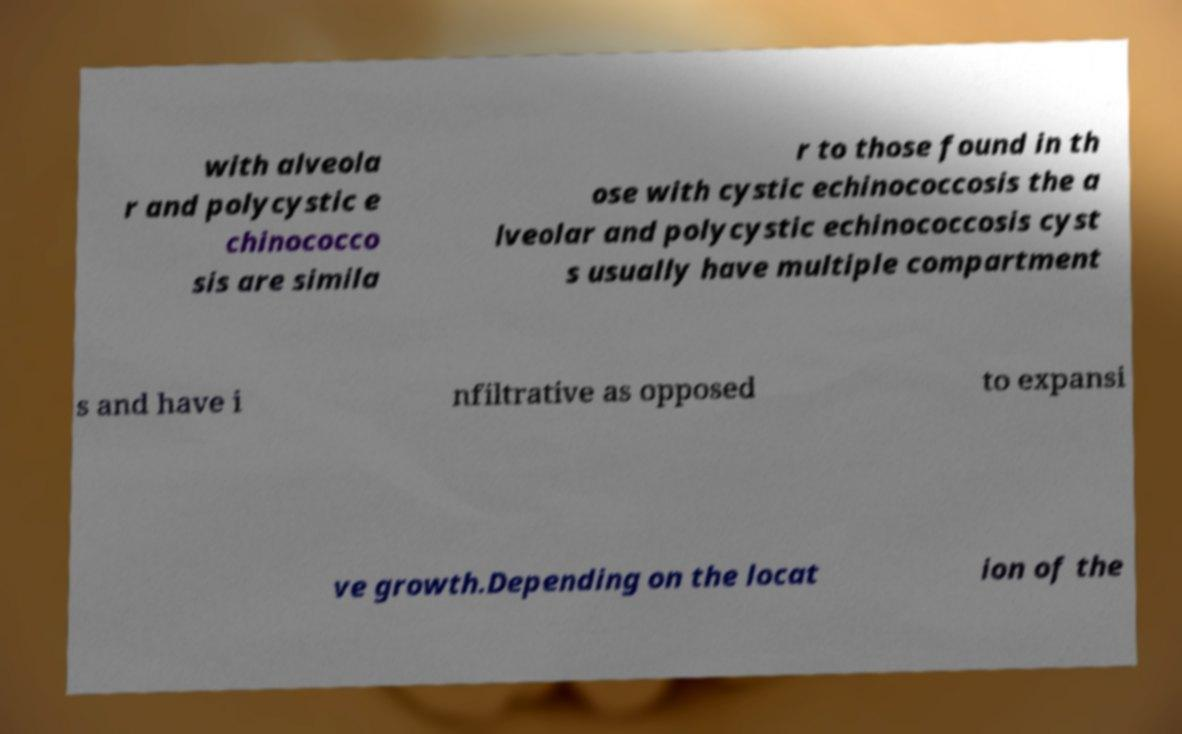What messages or text are displayed in this image? I need them in a readable, typed format. with alveola r and polycystic e chinococco sis are simila r to those found in th ose with cystic echinococcosis the a lveolar and polycystic echinococcosis cyst s usually have multiple compartment s and have i nfiltrative as opposed to expansi ve growth.Depending on the locat ion of the 